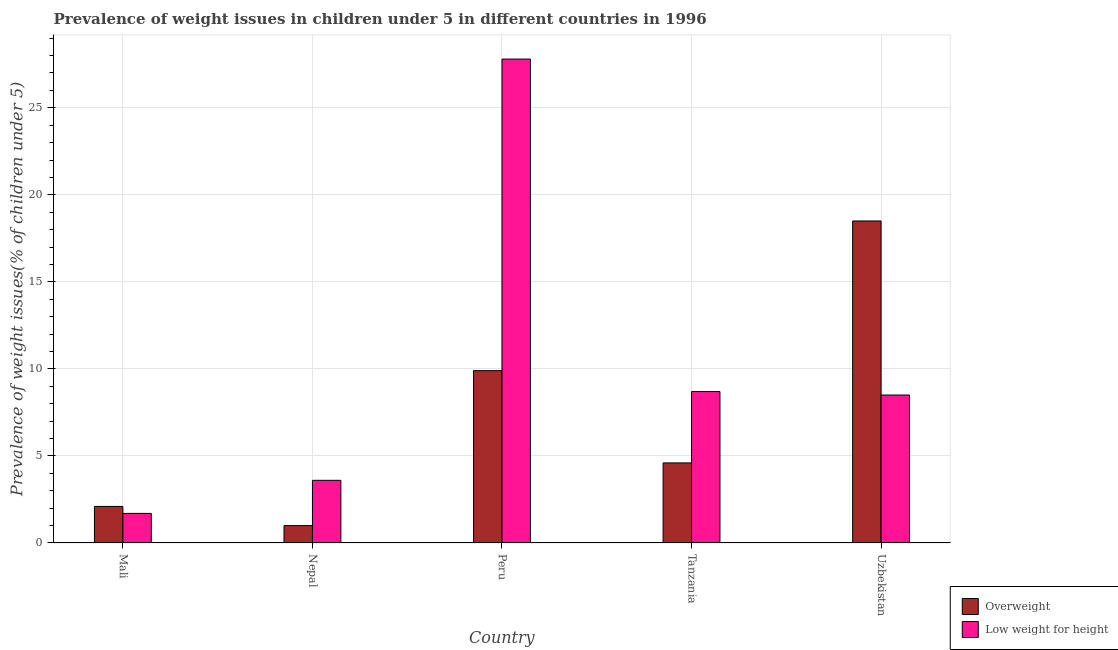How many different coloured bars are there?
Offer a very short reply. 2. How many groups of bars are there?
Offer a terse response. 5. How many bars are there on the 3rd tick from the left?
Your answer should be very brief. 2. What is the label of the 5th group of bars from the left?
Give a very brief answer. Uzbekistan. In how many cases, is the number of bars for a given country not equal to the number of legend labels?
Give a very brief answer. 0. What is the percentage of underweight children in Nepal?
Give a very brief answer. 3.6. Across all countries, what is the maximum percentage of underweight children?
Keep it short and to the point. 27.8. In which country was the percentage of overweight children maximum?
Ensure brevity in your answer.  Uzbekistan. In which country was the percentage of underweight children minimum?
Ensure brevity in your answer.  Mali. What is the total percentage of overweight children in the graph?
Provide a short and direct response. 36.1. What is the difference between the percentage of underweight children in Tanzania and that in Uzbekistan?
Give a very brief answer. 0.2. What is the difference between the percentage of overweight children in Uzbekistan and the percentage of underweight children in Nepal?
Your answer should be compact. 14.9. What is the average percentage of overweight children per country?
Make the answer very short. 7.22. What is the difference between the percentage of overweight children and percentage of underweight children in Uzbekistan?
Provide a succinct answer. 10. What is the ratio of the percentage of overweight children in Mali to that in Peru?
Provide a succinct answer. 0.21. Is the difference between the percentage of underweight children in Peru and Uzbekistan greater than the difference between the percentage of overweight children in Peru and Uzbekistan?
Provide a short and direct response. Yes. What is the difference between the highest and the second highest percentage of overweight children?
Give a very brief answer. 8.6. What is the difference between the highest and the lowest percentage of underweight children?
Give a very brief answer. 26.1. In how many countries, is the percentage of overweight children greater than the average percentage of overweight children taken over all countries?
Your response must be concise. 2. What does the 2nd bar from the left in Mali represents?
Offer a very short reply. Low weight for height. What does the 1st bar from the right in Peru represents?
Your response must be concise. Low weight for height. How many bars are there?
Provide a succinct answer. 10. How many countries are there in the graph?
Keep it short and to the point. 5. Are the values on the major ticks of Y-axis written in scientific E-notation?
Your response must be concise. No. Does the graph contain grids?
Provide a succinct answer. Yes. Where does the legend appear in the graph?
Make the answer very short. Bottom right. What is the title of the graph?
Your response must be concise. Prevalence of weight issues in children under 5 in different countries in 1996. What is the label or title of the X-axis?
Offer a very short reply. Country. What is the label or title of the Y-axis?
Make the answer very short. Prevalence of weight issues(% of children under 5). What is the Prevalence of weight issues(% of children under 5) of Overweight in Mali?
Ensure brevity in your answer.  2.1. What is the Prevalence of weight issues(% of children under 5) in Low weight for height in Mali?
Offer a very short reply. 1.7. What is the Prevalence of weight issues(% of children under 5) in Low weight for height in Nepal?
Keep it short and to the point. 3.6. What is the Prevalence of weight issues(% of children under 5) in Overweight in Peru?
Your answer should be very brief. 9.9. What is the Prevalence of weight issues(% of children under 5) of Low weight for height in Peru?
Keep it short and to the point. 27.8. What is the Prevalence of weight issues(% of children under 5) in Overweight in Tanzania?
Your answer should be compact. 4.6. What is the Prevalence of weight issues(% of children under 5) in Low weight for height in Tanzania?
Your answer should be very brief. 8.7. What is the Prevalence of weight issues(% of children under 5) of Low weight for height in Uzbekistan?
Your answer should be very brief. 8.5. Across all countries, what is the maximum Prevalence of weight issues(% of children under 5) in Low weight for height?
Ensure brevity in your answer.  27.8. Across all countries, what is the minimum Prevalence of weight issues(% of children under 5) in Low weight for height?
Ensure brevity in your answer.  1.7. What is the total Prevalence of weight issues(% of children under 5) in Overweight in the graph?
Ensure brevity in your answer.  36.1. What is the total Prevalence of weight issues(% of children under 5) in Low weight for height in the graph?
Provide a short and direct response. 50.3. What is the difference between the Prevalence of weight issues(% of children under 5) in Overweight in Mali and that in Nepal?
Give a very brief answer. 1.1. What is the difference between the Prevalence of weight issues(% of children under 5) in Overweight in Mali and that in Peru?
Provide a short and direct response. -7.8. What is the difference between the Prevalence of weight issues(% of children under 5) in Low weight for height in Mali and that in Peru?
Give a very brief answer. -26.1. What is the difference between the Prevalence of weight issues(% of children under 5) in Overweight in Mali and that in Tanzania?
Provide a succinct answer. -2.5. What is the difference between the Prevalence of weight issues(% of children under 5) of Overweight in Mali and that in Uzbekistan?
Provide a short and direct response. -16.4. What is the difference between the Prevalence of weight issues(% of children under 5) of Low weight for height in Mali and that in Uzbekistan?
Give a very brief answer. -6.8. What is the difference between the Prevalence of weight issues(% of children under 5) in Low weight for height in Nepal and that in Peru?
Give a very brief answer. -24.2. What is the difference between the Prevalence of weight issues(% of children under 5) of Overweight in Nepal and that in Tanzania?
Ensure brevity in your answer.  -3.6. What is the difference between the Prevalence of weight issues(% of children under 5) in Low weight for height in Nepal and that in Tanzania?
Offer a terse response. -5.1. What is the difference between the Prevalence of weight issues(% of children under 5) of Overweight in Nepal and that in Uzbekistan?
Provide a succinct answer. -17.5. What is the difference between the Prevalence of weight issues(% of children under 5) of Low weight for height in Nepal and that in Uzbekistan?
Make the answer very short. -4.9. What is the difference between the Prevalence of weight issues(% of children under 5) of Overweight in Peru and that in Tanzania?
Your answer should be compact. 5.3. What is the difference between the Prevalence of weight issues(% of children under 5) of Low weight for height in Peru and that in Tanzania?
Provide a succinct answer. 19.1. What is the difference between the Prevalence of weight issues(% of children under 5) in Overweight in Peru and that in Uzbekistan?
Ensure brevity in your answer.  -8.6. What is the difference between the Prevalence of weight issues(% of children under 5) of Low weight for height in Peru and that in Uzbekistan?
Offer a very short reply. 19.3. What is the difference between the Prevalence of weight issues(% of children under 5) in Overweight in Tanzania and that in Uzbekistan?
Make the answer very short. -13.9. What is the difference between the Prevalence of weight issues(% of children under 5) of Low weight for height in Tanzania and that in Uzbekistan?
Your response must be concise. 0.2. What is the difference between the Prevalence of weight issues(% of children under 5) in Overweight in Mali and the Prevalence of weight issues(% of children under 5) in Low weight for height in Peru?
Your answer should be very brief. -25.7. What is the difference between the Prevalence of weight issues(% of children under 5) in Overweight in Nepal and the Prevalence of weight issues(% of children under 5) in Low weight for height in Peru?
Your answer should be compact. -26.8. What is the difference between the Prevalence of weight issues(% of children under 5) in Overweight in Nepal and the Prevalence of weight issues(% of children under 5) in Low weight for height in Uzbekistan?
Provide a short and direct response. -7.5. What is the difference between the Prevalence of weight issues(% of children under 5) in Overweight in Peru and the Prevalence of weight issues(% of children under 5) in Low weight for height in Tanzania?
Ensure brevity in your answer.  1.2. What is the difference between the Prevalence of weight issues(% of children under 5) in Overweight in Tanzania and the Prevalence of weight issues(% of children under 5) in Low weight for height in Uzbekistan?
Keep it short and to the point. -3.9. What is the average Prevalence of weight issues(% of children under 5) of Overweight per country?
Give a very brief answer. 7.22. What is the average Prevalence of weight issues(% of children under 5) in Low weight for height per country?
Make the answer very short. 10.06. What is the difference between the Prevalence of weight issues(% of children under 5) of Overweight and Prevalence of weight issues(% of children under 5) of Low weight for height in Nepal?
Your response must be concise. -2.6. What is the difference between the Prevalence of weight issues(% of children under 5) of Overweight and Prevalence of weight issues(% of children under 5) of Low weight for height in Peru?
Provide a succinct answer. -17.9. What is the difference between the Prevalence of weight issues(% of children under 5) in Overweight and Prevalence of weight issues(% of children under 5) in Low weight for height in Tanzania?
Offer a very short reply. -4.1. What is the difference between the Prevalence of weight issues(% of children under 5) of Overweight and Prevalence of weight issues(% of children under 5) of Low weight for height in Uzbekistan?
Give a very brief answer. 10. What is the ratio of the Prevalence of weight issues(% of children under 5) of Low weight for height in Mali to that in Nepal?
Give a very brief answer. 0.47. What is the ratio of the Prevalence of weight issues(% of children under 5) of Overweight in Mali to that in Peru?
Your answer should be very brief. 0.21. What is the ratio of the Prevalence of weight issues(% of children under 5) in Low weight for height in Mali to that in Peru?
Keep it short and to the point. 0.06. What is the ratio of the Prevalence of weight issues(% of children under 5) in Overweight in Mali to that in Tanzania?
Ensure brevity in your answer.  0.46. What is the ratio of the Prevalence of weight issues(% of children under 5) of Low weight for height in Mali to that in Tanzania?
Give a very brief answer. 0.2. What is the ratio of the Prevalence of weight issues(% of children under 5) in Overweight in Mali to that in Uzbekistan?
Your response must be concise. 0.11. What is the ratio of the Prevalence of weight issues(% of children under 5) of Overweight in Nepal to that in Peru?
Offer a terse response. 0.1. What is the ratio of the Prevalence of weight issues(% of children under 5) in Low weight for height in Nepal to that in Peru?
Provide a succinct answer. 0.13. What is the ratio of the Prevalence of weight issues(% of children under 5) of Overweight in Nepal to that in Tanzania?
Your answer should be very brief. 0.22. What is the ratio of the Prevalence of weight issues(% of children under 5) in Low weight for height in Nepal to that in Tanzania?
Ensure brevity in your answer.  0.41. What is the ratio of the Prevalence of weight issues(% of children under 5) of Overweight in Nepal to that in Uzbekistan?
Your response must be concise. 0.05. What is the ratio of the Prevalence of weight issues(% of children under 5) of Low weight for height in Nepal to that in Uzbekistan?
Make the answer very short. 0.42. What is the ratio of the Prevalence of weight issues(% of children under 5) in Overweight in Peru to that in Tanzania?
Keep it short and to the point. 2.15. What is the ratio of the Prevalence of weight issues(% of children under 5) in Low weight for height in Peru to that in Tanzania?
Give a very brief answer. 3.2. What is the ratio of the Prevalence of weight issues(% of children under 5) of Overweight in Peru to that in Uzbekistan?
Offer a very short reply. 0.54. What is the ratio of the Prevalence of weight issues(% of children under 5) in Low weight for height in Peru to that in Uzbekistan?
Your response must be concise. 3.27. What is the ratio of the Prevalence of weight issues(% of children under 5) of Overweight in Tanzania to that in Uzbekistan?
Offer a very short reply. 0.25. What is the ratio of the Prevalence of weight issues(% of children under 5) of Low weight for height in Tanzania to that in Uzbekistan?
Offer a terse response. 1.02. What is the difference between the highest and the second highest Prevalence of weight issues(% of children under 5) in Overweight?
Keep it short and to the point. 8.6. What is the difference between the highest and the lowest Prevalence of weight issues(% of children under 5) in Low weight for height?
Provide a short and direct response. 26.1. 